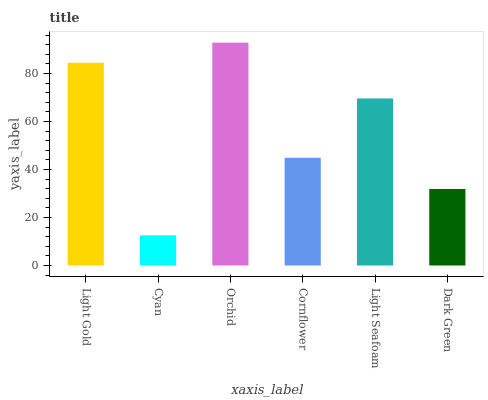Is Cyan the minimum?
Answer yes or no. Yes. Is Orchid the maximum?
Answer yes or no. Yes. Is Orchid the minimum?
Answer yes or no. No. Is Cyan the maximum?
Answer yes or no. No. Is Orchid greater than Cyan?
Answer yes or no. Yes. Is Cyan less than Orchid?
Answer yes or no. Yes. Is Cyan greater than Orchid?
Answer yes or no. No. Is Orchid less than Cyan?
Answer yes or no. No. Is Light Seafoam the high median?
Answer yes or no. Yes. Is Cornflower the low median?
Answer yes or no. Yes. Is Dark Green the high median?
Answer yes or no. No. Is Light Seafoam the low median?
Answer yes or no. No. 